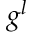<formula> <loc_0><loc_0><loc_500><loc_500>g ^ { l }</formula> 